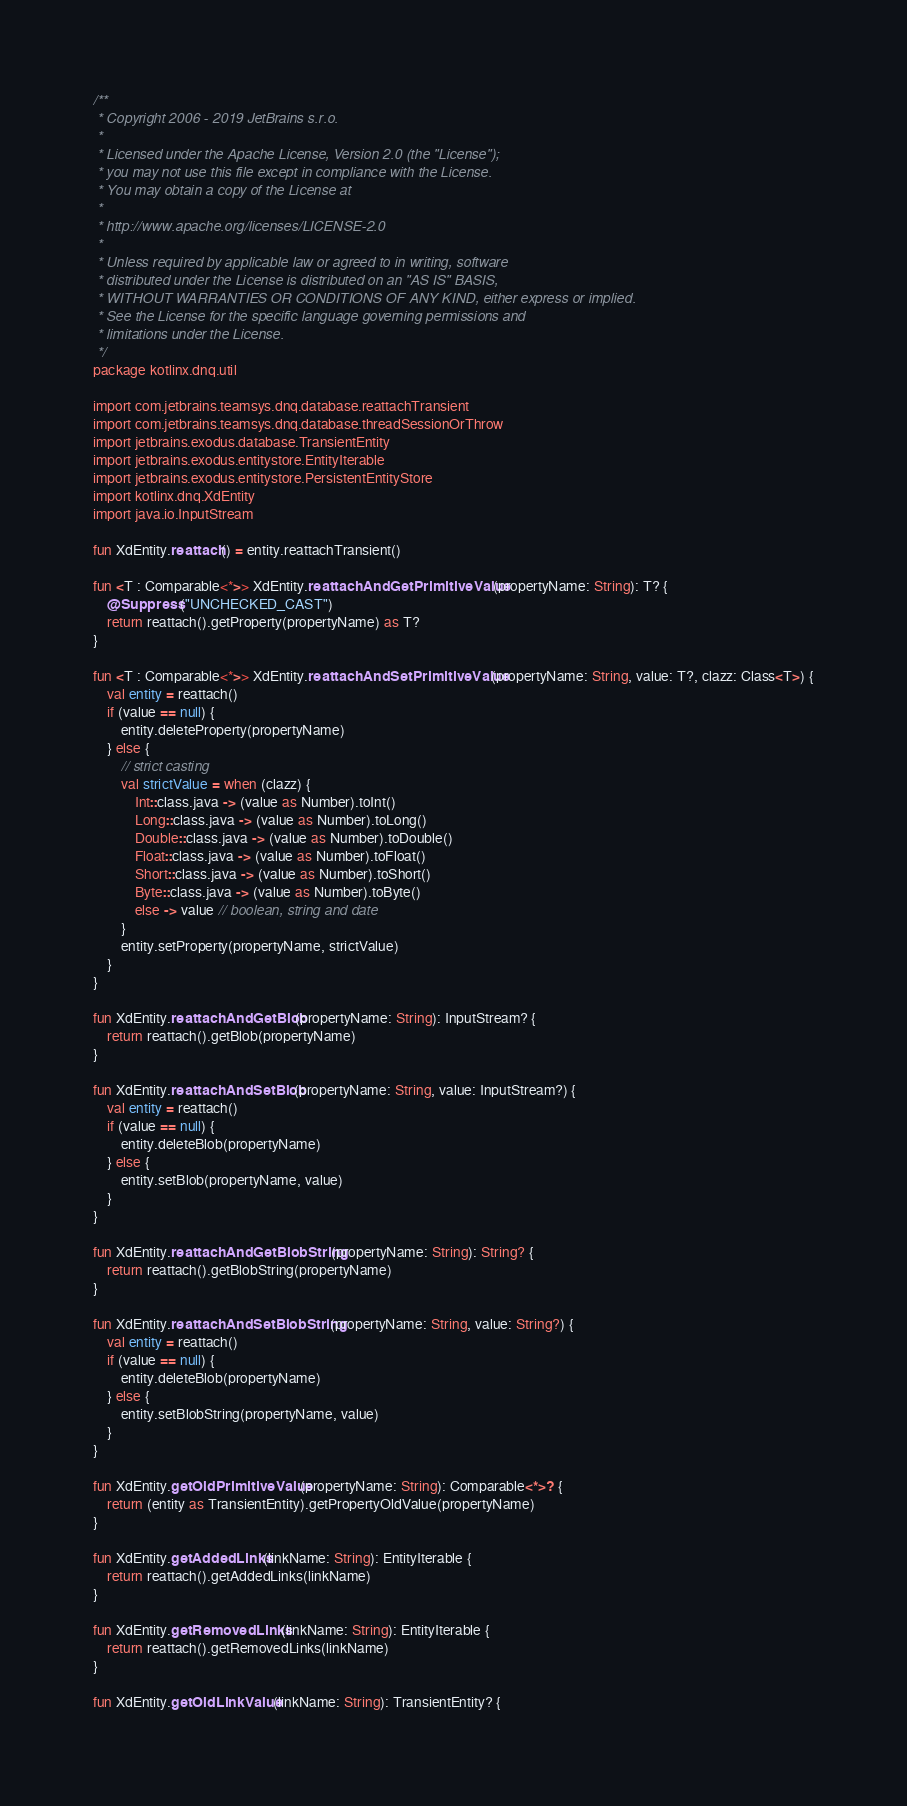Convert code to text. <code><loc_0><loc_0><loc_500><loc_500><_Kotlin_>/**
 * Copyright 2006 - 2019 JetBrains s.r.o.
 *
 * Licensed under the Apache License, Version 2.0 (the "License");
 * you may not use this file except in compliance with the License.
 * You may obtain a copy of the License at
 *
 * http://www.apache.org/licenses/LICENSE-2.0
 *
 * Unless required by applicable law or agreed to in writing, software
 * distributed under the License is distributed on an "AS IS" BASIS,
 * WITHOUT WARRANTIES OR CONDITIONS OF ANY KIND, either express or implied.
 * See the License for the specific language governing permissions and
 * limitations under the License.
 */
package kotlinx.dnq.util

import com.jetbrains.teamsys.dnq.database.reattachTransient
import com.jetbrains.teamsys.dnq.database.threadSessionOrThrow
import jetbrains.exodus.database.TransientEntity
import jetbrains.exodus.entitystore.EntityIterable
import jetbrains.exodus.entitystore.PersistentEntityStore
import kotlinx.dnq.XdEntity
import java.io.InputStream

fun XdEntity.reattach() = entity.reattachTransient()

fun <T : Comparable<*>> XdEntity.reattachAndGetPrimitiveValue(propertyName: String): T? {
    @Suppress("UNCHECKED_CAST")
    return reattach().getProperty(propertyName) as T?
}

fun <T : Comparable<*>> XdEntity.reattachAndSetPrimitiveValue(propertyName: String, value: T?, clazz: Class<T>) {
    val entity = reattach()
    if (value == null) {
        entity.deleteProperty(propertyName)
    } else {
        // strict casting
        val strictValue = when (clazz) {
            Int::class.java -> (value as Number).toInt()
            Long::class.java -> (value as Number).toLong()
            Double::class.java -> (value as Number).toDouble()
            Float::class.java -> (value as Number).toFloat()
            Short::class.java -> (value as Number).toShort()
            Byte::class.java -> (value as Number).toByte()
            else -> value // boolean, string and date
        }
        entity.setProperty(propertyName, strictValue)
    }
}

fun XdEntity.reattachAndGetBlob(propertyName: String): InputStream? {
    return reattach().getBlob(propertyName)
}

fun XdEntity.reattachAndSetBlob(propertyName: String, value: InputStream?) {
    val entity = reattach()
    if (value == null) {
        entity.deleteBlob(propertyName)
    } else {
        entity.setBlob(propertyName, value)
    }
}

fun XdEntity.reattachAndGetBlobString(propertyName: String): String? {
    return reattach().getBlobString(propertyName)
}

fun XdEntity.reattachAndSetBlobString(propertyName: String, value: String?) {
    val entity = reattach()
    if (value == null) {
        entity.deleteBlob(propertyName)
    } else {
        entity.setBlobString(propertyName, value)
    }
}

fun XdEntity.getOldPrimitiveValue(propertyName: String): Comparable<*>? {
    return (entity as TransientEntity).getPropertyOldValue(propertyName)
}

fun XdEntity.getAddedLinks(linkName: String): EntityIterable {
    return reattach().getAddedLinks(linkName)
}

fun XdEntity.getRemovedLinks(linkName: String): EntityIterable {
    return reattach().getRemovedLinks(linkName)
}

fun XdEntity.getOldLinkValue(linkName: String): TransientEntity? {</code> 